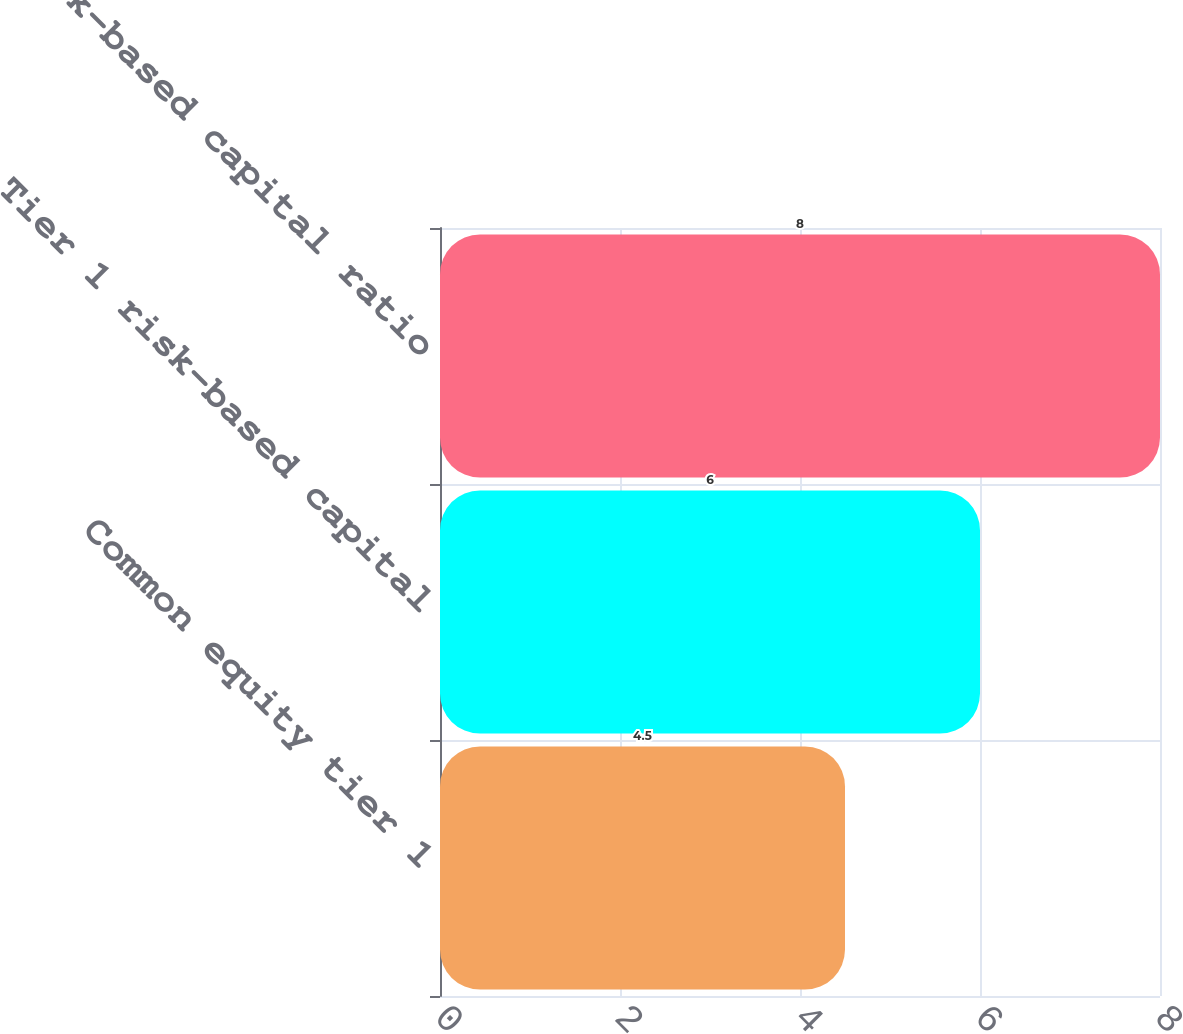<chart> <loc_0><loc_0><loc_500><loc_500><bar_chart><fcel>Common equity tier 1<fcel>Tier 1 risk-based capital<fcel>Total risk-based capital ratio<nl><fcel>4.5<fcel>6<fcel>8<nl></chart> 